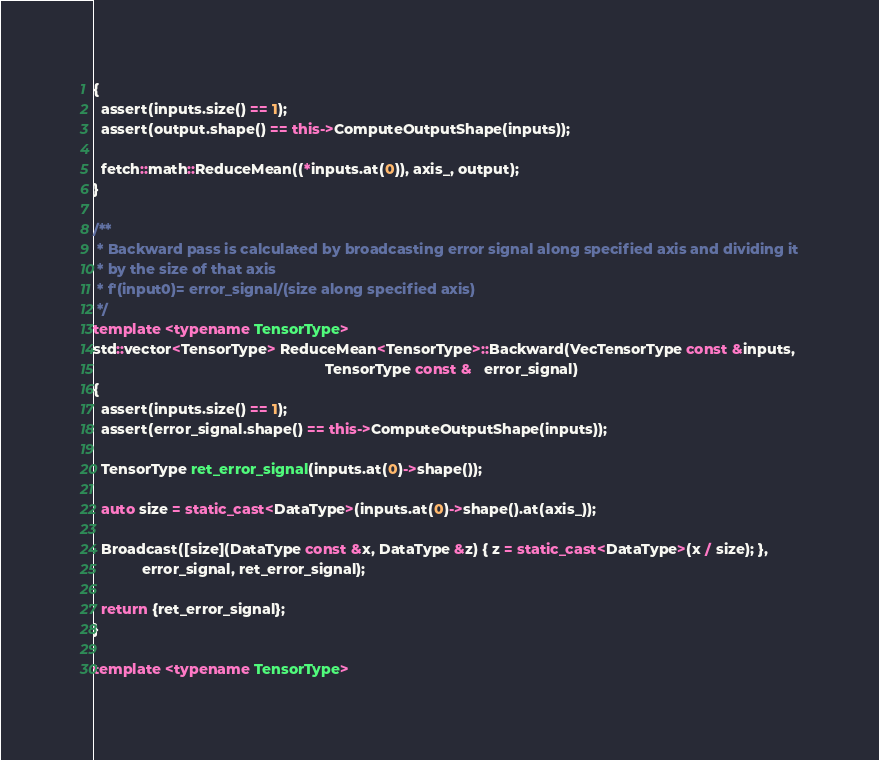<code> <loc_0><loc_0><loc_500><loc_500><_C++_>{
  assert(inputs.size() == 1);
  assert(output.shape() == this->ComputeOutputShape(inputs));

  fetch::math::ReduceMean((*inputs.at(0)), axis_, output);
}

/**
 * Backward pass is calculated by broadcasting error signal along specified axis and dividing it
 * by the size of that axis
 * f'(input0)= error_signal/(size along specified axis)
 */
template <typename TensorType>
std::vector<TensorType> ReduceMean<TensorType>::Backward(VecTensorType const &inputs,
                                                         TensorType const &   error_signal)
{
  assert(inputs.size() == 1);
  assert(error_signal.shape() == this->ComputeOutputShape(inputs));

  TensorType ret_error_signal(inputs.at(0)->shape());

  auto size = static_cast<DataType>(inputs.at(0)->shape().at(axis_));

  Broadcast([size](DataType const &x, DataType &z) { z = static_cast<DataType>(x / size); },
            error_signal, ret_error_signal);

  return {ret_error_signal};
}

template <typename TensorType></code> 